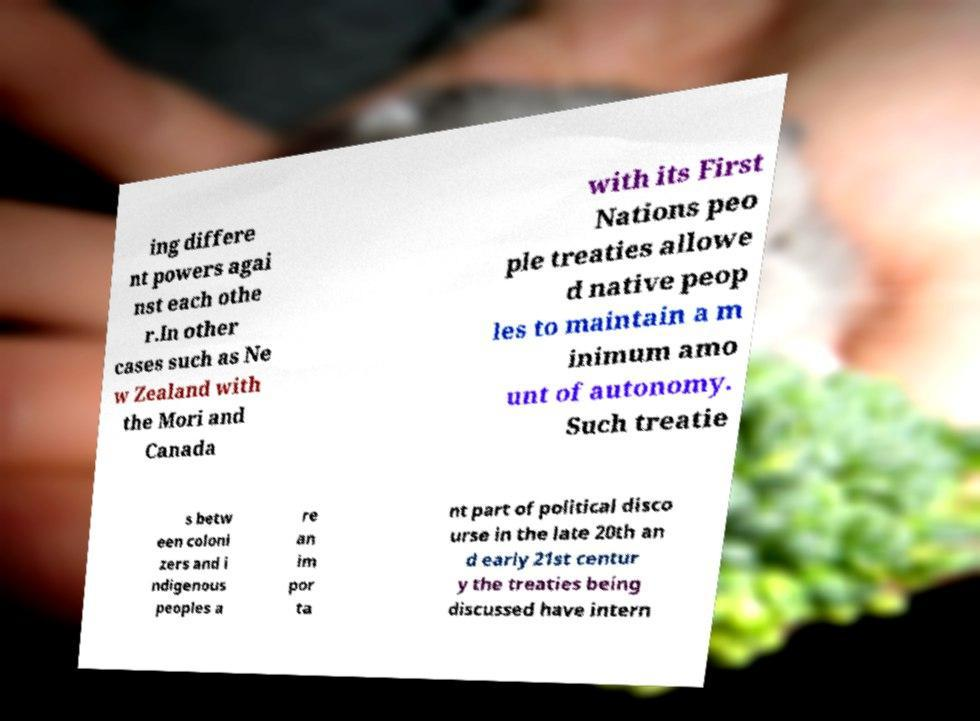What messages or text are displayed in this image? I need them in a readable, typed format. ing differe nt powers agai nst each othe r.In other cases such as Ne w Zealand with the Mori and Canada with its First Nations peo ple treaties allowe d native peop les to maintain a m inimum amo unt of autonomy. Such treatie s betw een coloni zers and i ndigenous peoples a re an im por ta nt part of political disco urse in the late 20th an d early 21st centur y the treaties being discussed have intern 